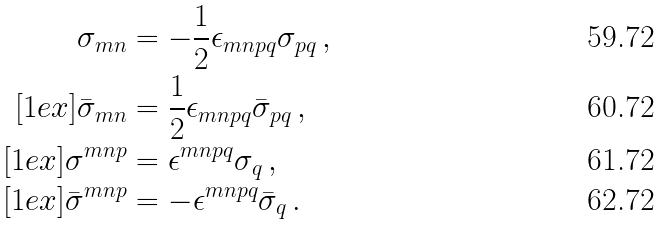<formula> <loc_0><loc_0><loc_500><loc_500>\sigma _ { m n } & = - \frac { 1 } { 2 } \epsilon _ { m n p q } \sigma _ { p q } \, , \\ [ 1 e x ] \bar { \sigma } _ { m n } & = \frac { 1 } { 2 } \epsilon _ { m n p q } \bar { \sigma } _ { p q } \, , \\ [ 1 e x ] \sigma ^ { m n p } & = \epsilon ^ { m n p q } \sigma _ { q } \, , \\ [ 1 e x ] \bar { \sigma } ^ { m n p } & = - \epsilon ^ { m n p q } \bar { \sigma } _ { q } \, .</formula> 